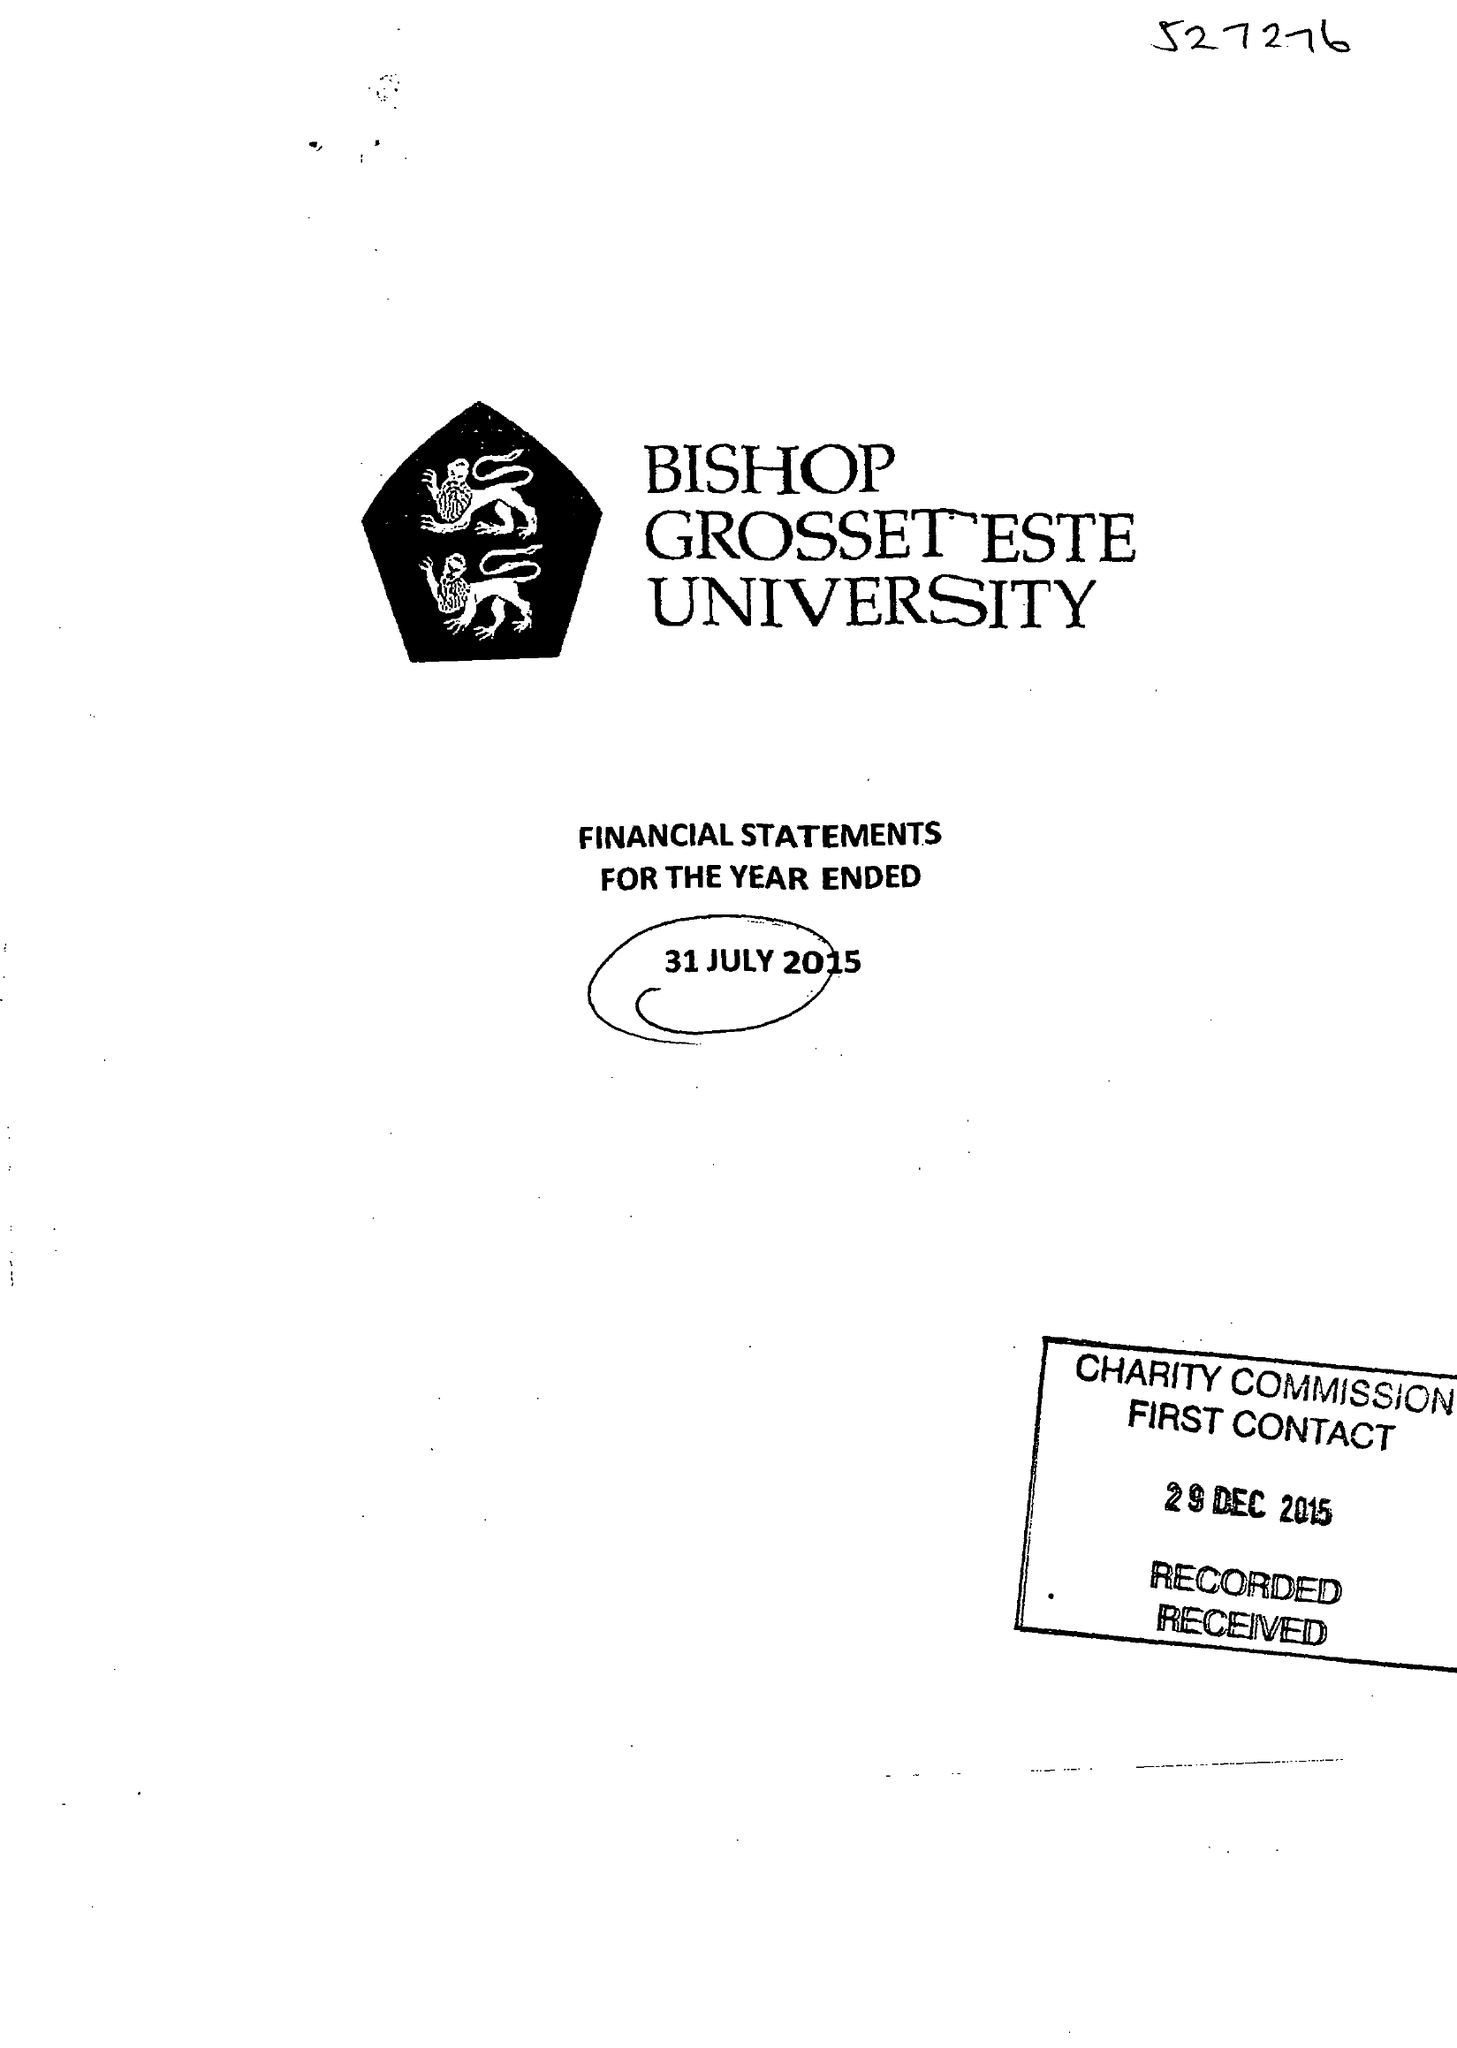What is the value for the address__postcode?
Answer the question using a single word or phrase. LN1 3DY 